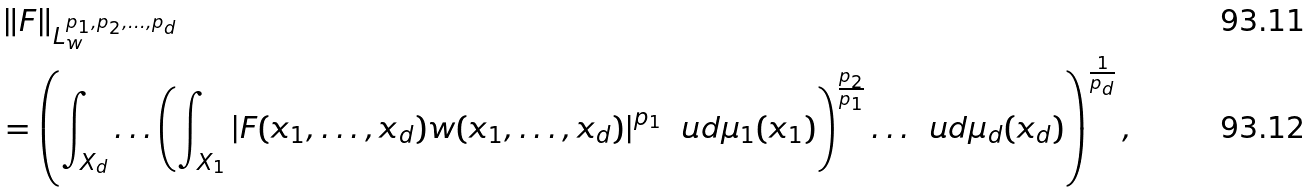<formula> <loc_0><loc_0><loc_500><loc_500>& \left \| F \right \| _ { L ^ { p _ { 1 } , p _ { 2 } , \dots , p _ { d } } _ { w } } \\ & = \left ( \int _ { X _ { d } } \dots \left ( \int _ { X _ { 1 } } \left | F ( x _ { 1 } , \dots , x _ { d } ) w ( x _ { 1 } , \dots , x _ { d } ) \right | ^ { p _ { 1 } } \, \ u d \mu _ { 1 } ( x _ { 1 } ) \right ) ^ { \frac { p _ { 2 } } { p _ { 1 } } } \dots \, \ u d \mu _ { d } ( x _ { d } ) \right ) ^ { \frac { 1 } { p _ { d } } } ,</formula> 